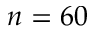Convert formula to latex. <formula><loc_0><loc_0><loc_500><loc_500>n = 6 0</formula> 